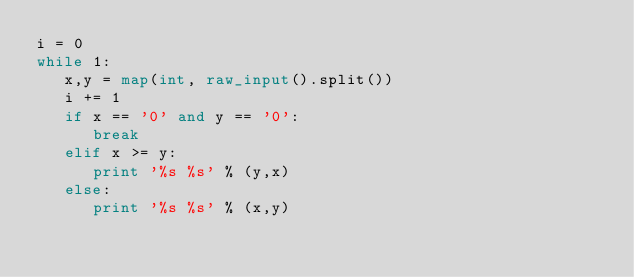Convert code to text. <code><loc_0><loc_0><loc_500><loc_500><_Python_>i = 0
while 1:
   x,y = map(int, raw_input().split())
   i += 1
   if x == '0' and y == '0':
      break
   elif x >= y:
      print '%s %s' % (y,x)
   else:
      print '%s %s' % (x,y)
   </code> 